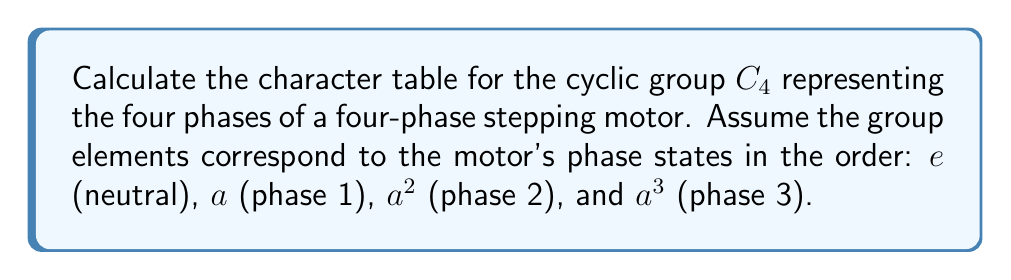Provide a solution to this math problem. To calculate the character table for the cyclic group $C_4$, we'll follow these steps:

1) First, recall that $C_4$ has four irreducible representations, all of dimension 1, because it's an abelian group.

2) The characters of these representations are given by:
   $$\chi_j(a^k) = e^{2\pi ijk/4} = i^{jk}$$
   where $j = 0, 1, 2, 3$ labels the representations and $k = 0, 1, 2, 3$ labels the group elements.

3) Let's calculate each character:

   For $\chi_0$ (trivial representation):
   $$\chi_0(e) = \chi_0(a) = \chi_0(a^2) = \chi_0(a^3) = 1$$

   For $\chi_1$:
   $$\chi_1(e) = 1, \chi_1(a) = i, \chi_1(a^2) = -1, \chi_1(a^3) = -i$$

   For $\chi_2$:
   $$\chi_2(e) = 1, \chi_2(a) = -1, \chi_2(a^2) = 1, \chi_2(a^3) = -1$$

   For $\chi_3$:
   $$\chi_3(e) = 1, \chi_3(a) = -i, \chi_3(a^2) = -1, \chi_3(a^3) = i$$

4) We can now construct the character table:

   $$\begin{array}{c|cccc}
     C_4 & e & a & a^2 & a^3 \\
     \hline
     \chi_0 & 1 & 1 & 1 & 1 \\
     \chi_1 & 1 & i & -1 & -i \\
     \chi_2 & 1 & -1 & 1 & -1 \\
     \chi_3 & 1 & -i & -1 & i
   \end{array}$$

5) In terms of the motor phases:
   - $e$ corresponds to the neutral state
   - $a$ corresponds to phase 1
   - $a^2$ corresponds to phase 2
   - $a^3$ corresponds to phase 3

This character table provides a complete description of how the four irreducible representations of $C_4$ behave under each phase of the stepping motor.
Answer: $$\begin{array}{c|cccc}
C_4 & e & a & a^2 & a^3 \\
\hline
\chi_0 & 1 & 1 & 1 & 1 \\
\chi_1 & 1 & i & -1 & -i \\
\chi_2 & 1 & -1 & 1 & -1 \\
\chi_3 & 1 & -i & -1 & i
\end{array}$$ 